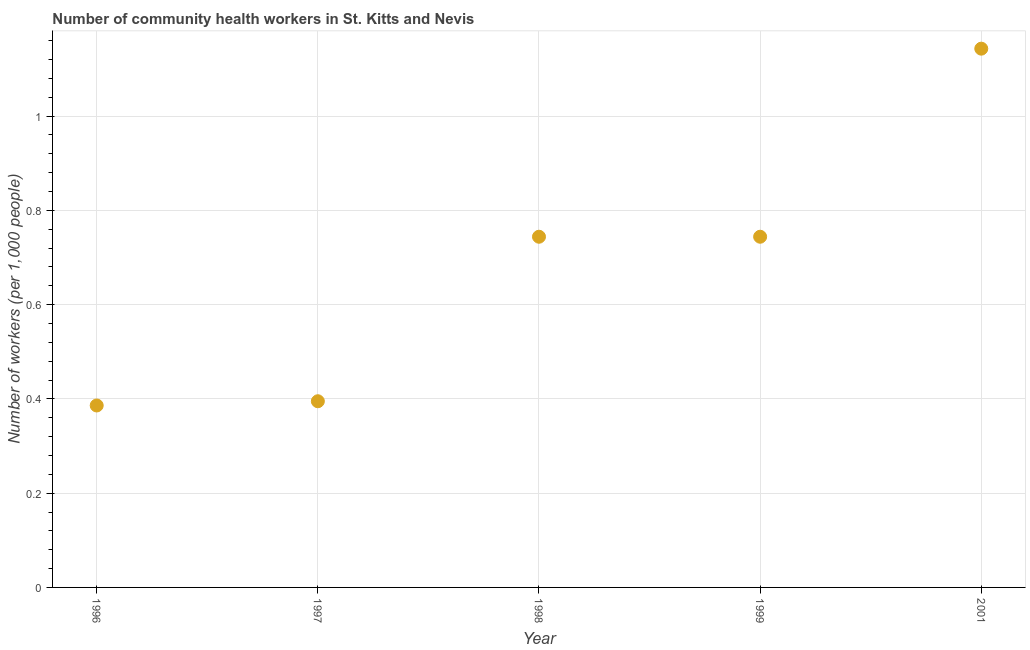What is the number of community health workers in 1998?
Your answer should be compact. 0.74. Across all years, what is the maximum number of community health workers?
Your response must be concise. 1.14. Across all years, what is the minimum number of community health workers?
Provide a short and direct response. 0.39. In which year was the number of community health workers maximum?
Provide a short and direct response. 2001. What is the sum of the number of community health workers?
Ensure brevity in your answer.  3.41. What is the difference between the number of community health workers in 1998 and 2001?
Ensure brevity in your answer.  -0.4. What is the average number of community health workers per year?
Keep it short and to the point. 0.68. What is the median number of community health workers?
Ensure brevity in your answer.  0.74. In how many years, is the number of community health workers greater than 0.8 ?
Your answer should be very brief. 1. Do a majority of the years between 1997 and 1999 (inclusive) have number of community health workers greater than 0.8400000000000001 ?
Provide a short and direct response. No. What is the ratio of the number of community health workers in 1997 to that in 1999?
Your answer should be compact. 0.53. What is the difference between the highest and the second highest number of community health workers?
Your answer should be compact. 0.4. Is the sum of the number of community health workers in 1997 and 2001 greater than the maximum number of community health workers across all years?
Keep it short and to the point. Yes. What is the difference between the highest and the lowest number of community health workers?
Make the answer very short. 0.76. In how many years, is the number of community health workers greater than the average number of community health workers taken over all years?
Your answer should be compact. 3. Does the number of community health workers monotonically increase over the years?
Give a very brief answer. No. How many years are there in the graph?
Your answer should be compact. 5. What is the difference between two consecutive major ticks on the Y-axis?
Make the answer very short. 0.2. Does the graph contain any zero values?
Your answer should be very brief. No. Does the graph contain grids?
Your answer should be very brief. Yes. What is the title of the graph?
Keep it short and to the point. Number of community health workers in St. Kitts and Nevis. What is the label or title of the Y-axis?
Make the answer very short. Number of workers (per 1,0 people). What is the Number of workers (per 1,000 people) in 1996?
Provide a succinct answer. 0.39. What is the Number of workers (per 1,000 people) in 1997?
Offer a very short reply. 0.4. What is the Number of workers (per 1,000 people) in 1998?
Give a very brief answer. 0.74. What is the Number of workers (per 1,000 people) in 1999?
Your response must be concise. 0.74. What is the Number of workers (per 1,000 people) in 2001?
Give a very brief answer. 1.14. What is the difference between the Number of workers (per 1,000 people) in 1996 and 1997?
Your answer should be very brief. -0.01. What is the difference between the Number of workers (per 1,000 people) in 1996 and 1998?
Give a very brief answer. -0.36. What is the difference between the Number of workers (per 1,000 people) in 1996 and 1999?
Your answer should be very brief. -0.36. What is the difference between the Number of workers (per 1,000 people) in 1996 and 2001?
Give a very brief answer. -0.76. What is the difference between the Number of workers (per 1,000 people) in 1997 and 1998?
Provide a short and direct response. -0.35. What is the difference between the Number of workers (per 1,000 people) in 1997 and 1999?
Give a very brief answer. -0.35. What is the difference between the Number of workers (per 1,000 people) in 1997 and 2001?
Provide a succinct answer. -0.75. What is the difference between the Number of workers (per 1,000 people) in 1998 and 2001?
Your answer should be compact. -0.4. What is the difference between the Number of workers (per 1,000 people) in 1999 and 2001?
Provide a succinct answer. -0.4. What is the ratio of the Number of workers (per 1,000 people) in 1996 to that in 1997?
Provide a succinct answer. 0.98. What is the ratio of the Number of workers (per 1,000 people) in 1996 to that in 1998?
Your answer should be very brief. 0.52. What is the ratio of the Number of workers (per 1,000 people) in 1996 to that in 1999?
Give a very brief answer. 0.52. What is the ratio of the Number of workers (per 1,000 people) in 1996 to that in 2001?
Give a very brief answer. 0.34. What is the ratio of the Number of workers (per 1,000 people) in 1997 to that in 1998?
Offer a terse response. 0.53. What is the ratio of the Number of workers (per 1,000 people) in 1997 to that in 1999?
Your answer should be very brief. 0.53. What is the ratio of the Number of workers (per 1,000 people) in 1997 to that in 2001?
Provide a succinct answer. 0.35. What is the ratio of the Number of workers (per 1,000 people) in 1998 to that in 2001?
Make the answer very short. 0.65. What is the ratio of the Number of workers (per 1,000 people) in 1999 to that in 2001?
Offer a very short reply. 0.65. 